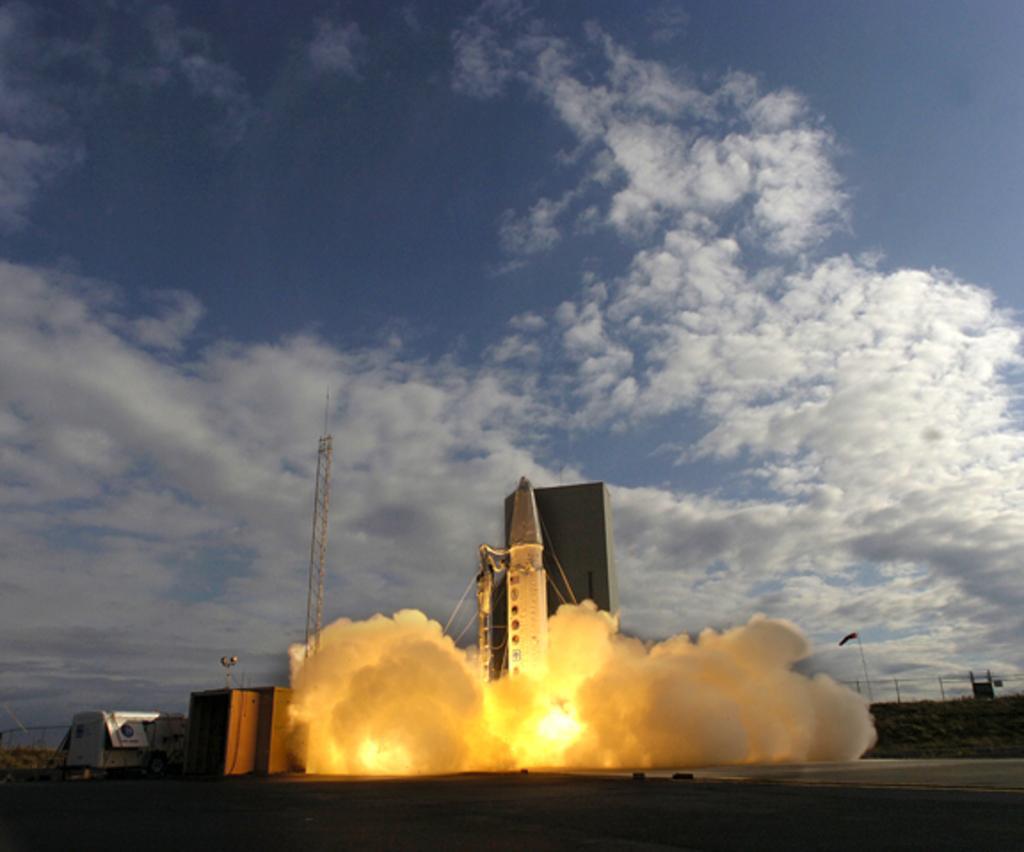Describe this image in one or two sentences. In this image there is a rocket, there is a tower, there is fire, there is smoke, there are objectś on the ground, there is fencing, there are cloudś in the sky. 